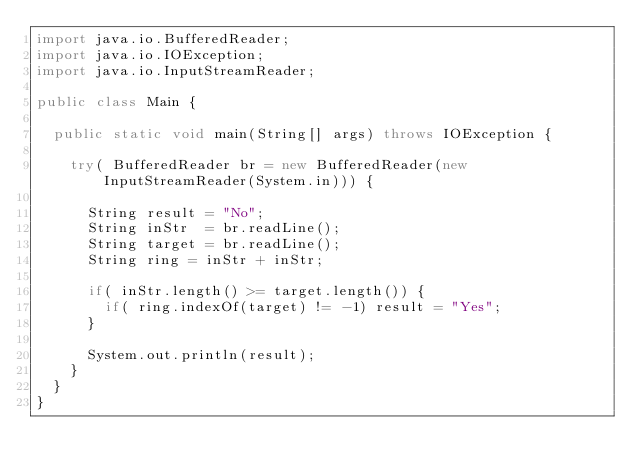<code> <loc_0><loc_0><loc_500><loc_500><_Java_>import java.io.BufferedReader;
import java.io.IOException;
import java.io.InputStreamReader;

public class Main {

  public static void main(String[] args) throws IOException {
    
    try( BufferedReader br = new BufferedReader(new InputStreamReader(System.in))) {

      String result = "No";
      String inStr  = br.readLine();
      String target = br.readLine();
      String ring = inStr + inStr;

      if( inStr.length() >= target.length()) {
        if( ring.indexOf(target) != -1) result = "Yes";
      }

      System.out.println(result);
    }
  }
}
</code> 